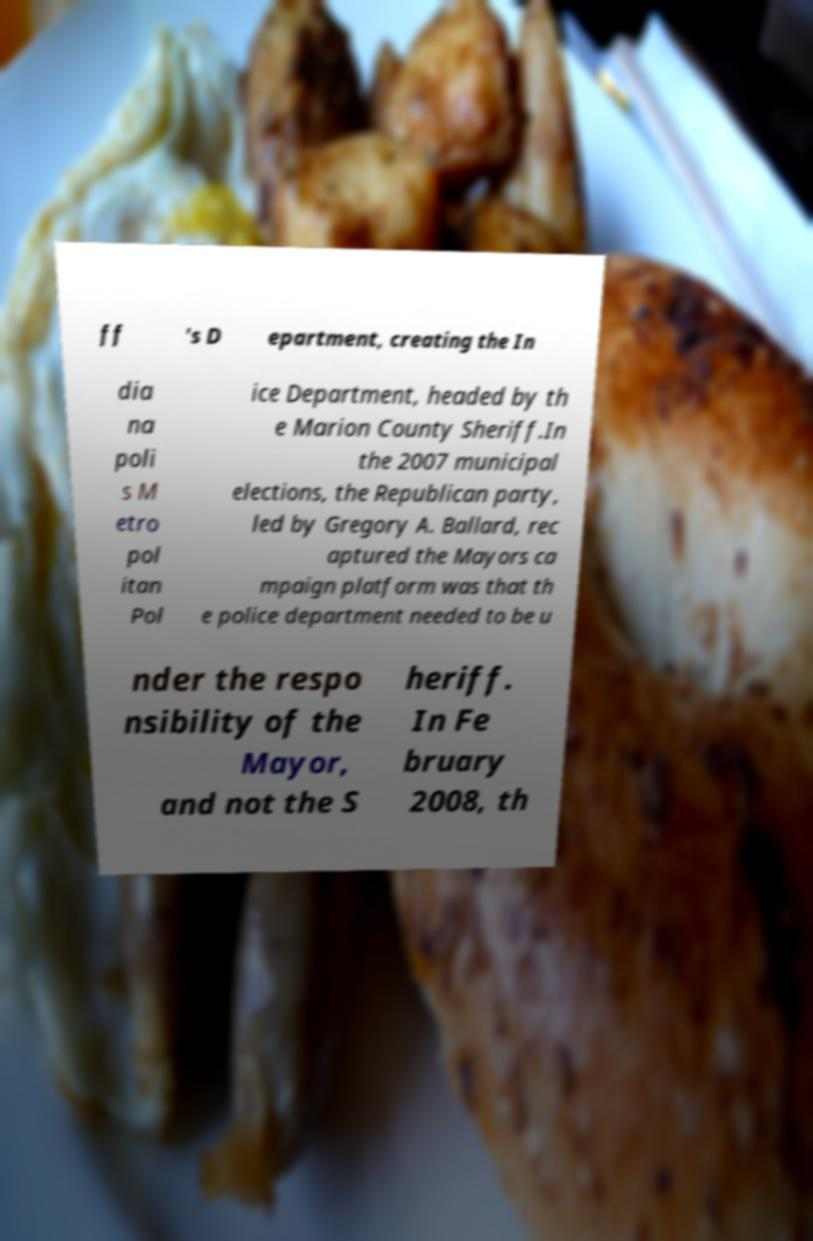Could you extract and type out the text from this image? ff 's D epartment, creating the In dia na poli s M etro pol itan Pol ice Department, headed by th e Marion County Sheriff.In the 2007 municipal elections, the Republican party, led by Gregory A. Ballard, rec aptured the Mayors ca mpaign platform was that th e police department needed to be u nder the respo nsibility of the Mayor, and not the S heriff. In Fe bruary 2008, th 